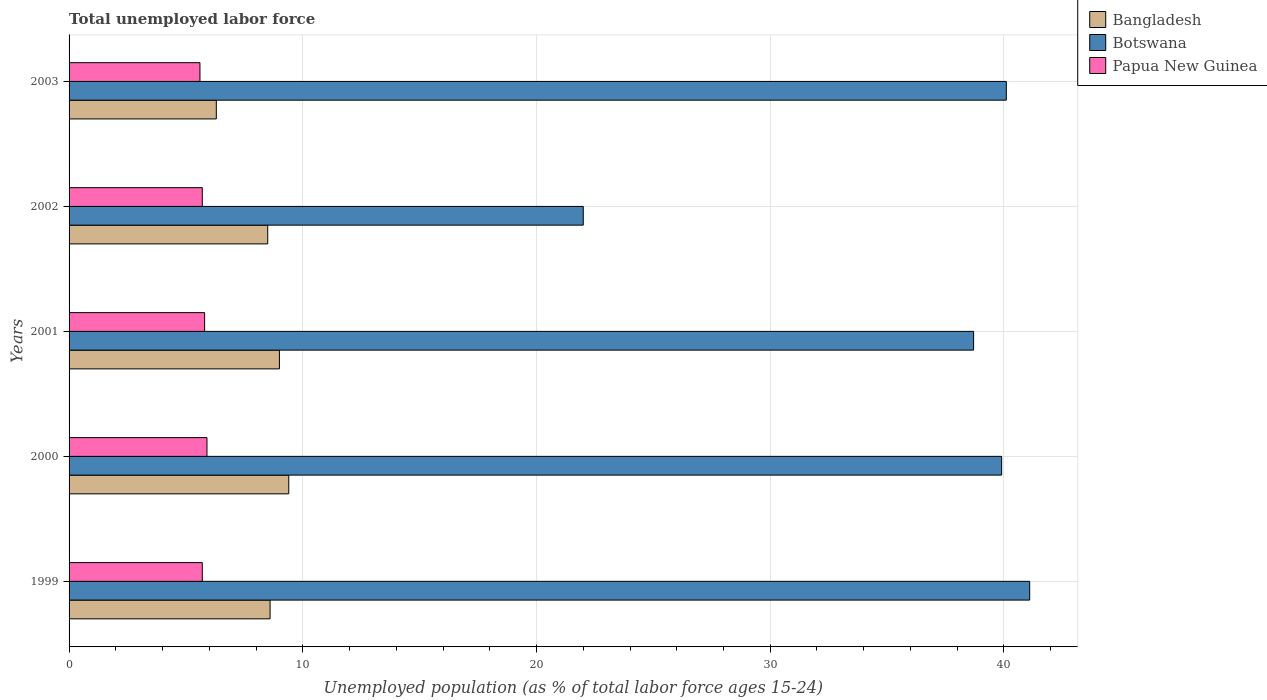How many different coloured bars are there?
Your answer should be compact. 3. How many groups of bars are there?
Offer a terse response. 5. What is the percentage of unemployed population in in Bangladesh in 1999?
Ensure brevity in your answer.  8.6. Across all years, what is the maximum percentage of unemployed population in in Papua New Guinea?
Provide a succinct answer. 5.9. Across all years, what is the minimum percentage of unemployed population in in Botswana?
Give a very brief answer. 22. In which year was the percentage of unemployed population in in Bangladesh maximum?
Your answer should be very brief. 2000. What is the total percentage of unemployed population in in Bangladesh in the graph?
Your response must be concise. 41.8. What is the difference between the percentage of unemployed population in in Botswana in 2001 and that in 2002?
Your answer should be compact. 16.7. What is the difference between the percentage of unemployed population in in Papua New Guinea in 2003 and the percentage of unemployed population in in Botswana in 2002?
Make the answer very short. -16.4. What is the average percentage of unemployed population in in Bangladesh per year?
Keep it short and to the point. 8.36. In the year 2001, what is the difference between the percentage of unemployed population in in Papua New Guinea and percentage of unemployed population in in Botswana?
Make the answer very short. -32.9. What is the ratio of the percentage of unemployed population in in Bangladesh in 2002 to that in 2003?
Offer a terse response. 1.35. Is the percentage of unemployed population in in Papua New Guinea in 2000 less than that in 2003?
Give a very brief answer. No. Is the difference between the percentage of unemployed population in in Papua New Guinea in 2001 and 2003 greater than the difference between the percentage of unemployed population in in Botswana in 2001 and 2003?
Provide a short and direct response. Yes. What is the difference between the highest and the second highest percentage of unemployed population in in Papua New Guinea?
Give a very brief answer. 0.1. What is the difference between the highest and the lowest percentage of unemployed population in in Bangladesh?
Keep it short and to the point. 3.1. Is the sum of the percentage of unemployed population in in Papua New Guinea in 1999 and 2002 greater than the maximum percentage of unemployed population in in Botswana across all years?
Give a very brief answer. No. What does the 1st bar from the top in 2000 represents?
Offer a very short reply. Papua New Guinea. How many bars are there?
Provide a short and direct response. 15. Does the graph contain any zero values?
Make the answer very short. No. Where does the legend appear in the graph?
Your answer should be compact. Top right. How many legend labels are there?
Your answer should be compact. 3. What is the title of the graph?
Provide a short and direct response. Total unemployed labor force. What is the label or title of the X-axis?
Offer a terse response. Unemployed population (as % of total labor force ages 15-24). What is the label or title of the Y-axis?
Your response must be concise. Years. What is the Unemployed population (as % of total labor force ages 15-24) in Bangladesh in 1999?
Your answer should be compact. 8.6. What is the Unemployed population (as % of total labor force ages 15-24) of Botswana in 1999?
Make the answer very short. 41.1. What is the Unemployed population (as % of total labor force ages 15-24) of Papua New Guinea in 1999?
Your answer should be very brief. 5.7. What is the Unemployed population (as % of total labor force ages 15-24) in Bangladesh in 2000?
Make the answer very short. 9.4. What is the Unemployed population (as % of total labor force ages 15-24) in Botswana in 2000?
Offer a very short reply. 39.9. What is the Unemployed population (as % of total labor force ages 15-24) of Papua New Guinea in 2000?
Offer a very short reply. 5.9. What is the Unemployed population (as % of total labor force ages 15-24) in Bangladesh in 2001?
Offer a very short reply. 9. What is the Unemployed population (as % of total labor force ages 15-24) in Botswana in 2001?
Your answer should be compact. 38.7. What is the Unemployed population (as % of total labor force ages 15-24) of Papua New Guinea in 2001?
Offer a terse response. 5.8. What is the Unemployed population (as % of total labor force ages 15-24) in Papua New Guinea in 2002?
Your response must be concise. 5.7. What is the Unemployed population (as % of total labor force ages 15-24) of Bangladesh in 2003?
Offer a very short reply. 6.3. What is the Unemployed population (as % of total labor force ages 15-24) in Botswana in 2003?
Provide a succinct answer. 40.1. What is the Unemployed population (as % of total labor force ages 15-24) in Papua New Guinea in 2003?
Provide a succinct answer. 5.6. Across all years, what is the maximum Unemployed population (as % of total labor force ages 15-24) of Bangladesh?
Offer a very short reply. 9.4. Across all years, what is the maximum Unemployed population (as % of total labor force ages 15-24) in Botswana?
Your response must be concise. 41.1. Across all years, what is the maximum Unemployed population (as % of total labor force ages 15-24) of Papua New Guinea?
Offer a very short reply. 5.9. Across all years, what is the minimum Unemployed population (as % of total labor force ages 15-24) in Bangladesh?
Make the answer very short. 6.3. Across all years, what is the minimum Unemployed population (as % of total labor force ages 15-24) of Botswana?
Give a very brief answer. 22. Across all years, what is the minimum Unemployed population (as % of total labor force ages 15-24) of Papua New Guinea?
Your response must be concise. 5.6. What is the total Unemployed population (as % of total labor force ages 15-24) of Bangladesh in the graph?
Provide a short and direct response. 41.8. What is the total Unemployed population (as % of total labor force ages 15-24) of Botswana in the graph?
Give a very brief answer. 181.8. What is the total Unemployed population (as % of total labor force ages 15-24) in Papua New Guinea in the graph?
Keep it short and to the point. 28.7. What is the difference between the Unemployed population (as % of total labor force ages 15-24) of Papua New Guinea in 1999 and that in 2000?
Offer a terse response. -0.2. What is the difference between the Unemployed population (as % of total labor force ages 15-24) in Papua New Guinea in 1999 and that in 2001?
Provide a succinct answer. -0.1. What is the difference between the Unemployed population (as % of total labor force ages 15-24) of Bangladesh in 1999 and that in 2002?
Your response must be concise. 0.1. What is the difference between the Unemployed population (as % of total labor force ages 15-24) in Bangladesh in 1999 and that in 2003?
Offer a terse response. 2.3. What is the difference between the Unemployed population (as % of total labor force ages 15-24) in Papua New Guinea in 1999 and that in 2003?
Keep it short and to the point. 0.1. What is the difference between the Unemployed population (as % of total labor force ages 15-24) in Bangladesh in 2000 and that in 2002?
Offer a very short reply. 0.9. What is the difference between the Unemployed population (as % of total labor force ages 15-24) in Botswana in 2000 and that in 2002?
Provide a short and direct response. 17.9. What is the difference between the Unemployed population (as % of total labor force ages 15-24) in Papua New Guinea in 2000 and that in 2002?
Make the answer very short. 0.2. What is the difference between the Unemployed population (as % of total labor force ages 15-24) in Botswana in 2000 and that in 2003?
Make the answer very short. -0.2. What is the difference between the Unemployed population (as % of total labor force ages 15-24) of Papua New Guinea in 2001 and that in 2002?
Offer a terse response. 0.1. What is the difference between the Unemployed population (as % of total labor force ages 15-24) in Bangladesh in 2001 and that in 2003?
Your answer should be very brief. 2.7. What is the difference between the Unemployed population (as % of total labor force ages 15-24) of Botswana in 2001 and that in 2003?
Offer a very short reply. -1.4. What is the difference between the Unemployed population (as % of total labor force ages 15-24) in Botswana in 2002 and that in 2003?
Provide a short and direct response. -18.1. What is the difference between the Unemployed population (as % of total labor force ages 15-24) in Papua New Guinea in 2002 and that in 2003?
Make the answer very short. 0.1. What is the difference between the Unemployed population (as % of total labor force ages 15-24) of Bangladesh in 1999 and the Unemployed population (as % of total labor force ages 15-24) of Botswana in 2000?
Ensure brevity in your answer.  -31.3. What is the difference between the Unemployed population (as % of total labor force ages 15-24) of Botswana in 1999 and the Unemployed population (as % of total labor force ages 15-24) of Papua New Guinea in 2000?
Provide a succinct answer. 35.2. What is the difference between the Unemployed population (as % of total labor force ages 15-24) in Bangladesh in 1999 and the Unemployed population (as % of total labor force ages 15-24) in Botswana in 2001?
Your answer should be compact. -30.1. What is the difference between the Unemployed population (as % of total labor force ages 15-24) of Bangladesh in 1999 and the Unemployed population (as % of total labor force ages 15-24) of Papua New Guinea in 2001?
Provide a short and direct response. 2.8. What is the difference between the Unemployed population (as % of total labor force ages 15-24) of Botswana in 1999 and the Unemployed population (as % of total labor force ages 15-24) of Papua New Guinea in 2001?
Provide a short and direct response. 35.3. What is the difference between the Unemployed population (as % of total labor force ages 15-24) of Bangladesh in 1999 and the Unemployed population (as % of total labor force ages 15-24) of Papua New Guinea in 2002?
Give a very brief answer. 2.9. What is the difference between the Unemployed population (as % of total labor force ages 15-24) of Botswana in 1999 and the Unemployed population (as % of total labor force ages 15-24) of Papua New Guinea in 2002?
Give a very brief answer. 35.4. What is the difference between the Unemployed population (as % of total labor force ages 15-24) in Bangladesh in 1999 and the Unemployed population (as % of total labor force ages 15-24) in Botswana in 2003?
Make the answer very short. -31.5. What is the difference between the Unemployed population (as % of total labor force ages 15-24) of Botswana in 1999 and the Unemployed population (as % of total labor force ages 15-24) of Papua New Guinea in 2003?
Keep it short and to the point. 35.5. What is the difference between the Unemployed population (as % of total labor force ages 15-24) of Bangladesh in 2000 and the Unemployed population (as % of total labor force ages 15-24) of Botswana in 2001?
Provide a short and direct response. -29.3. What is the difference between the Unemployed population (as % of total labor force ages 15-24) in Botswana in 2000 and the Unemployed population (as % of total labor force ages 15-24) in Papua New Guinea in 2001?
Provide a short and direct response. 34.1. What is the difference between the Unemployed population (as % of total labor force ages 15-24) in Bangladesh in 2000 and the Unemployed population (as % of total labor force ages 15-24) in Botswana in 2002?
Keep it short and to the point. -12.6. What is the difference between the Unemployed population (as % of total labor force ages 15-24) in Botswana in 2000 and the Unemployed population (as % of total labor force ages 15-24) in Papua New Guinea in 2002?
Offer a very short reply. 34.2. What is the difference between the Unemployed population (as % of total labor force ages 15-24) of Bangladesh in 2000 and the Unemployed population (as % of total labor force ages 15-24) of Botswana in 2003?
Your response must be concise. -30.7. What is the difference between the Unemployed population (as % of total labor force ages 15-24) of Botswana in 2000 and the Unemployed population (as % of total labor force ages 15-24) of Papua New Guinea in 2003?
Make the answer very short. 34.3. What is the difference between the Unemployed population (as % of total labor force ages 15-24) of Bangladesh in 2001 and the Unemployed population (as % of total labor force ages 15-24) of Botswana in 2002?
Offer a terse response. -13. What is the difference between the Unemployed population (as % of total labor force ages 15-24) of Bangladesh in 2001 and the Unemployed population (as % of total labor force ages 15-24) of Papua New Guinea in 2002?
Offer a very short reply. 3.3. What is the difference between the Unemployed population (as % of total labor force ages 15-24) in Botswana in 2001 and the Unemployed population (as % of total labor force ages 15-24) in Papua New Guinea in 2002?
Offer a very short reply. 33. What is the difference between the Unemployed population (as % of total labor force ages 15-24) in Bangladesh in 2001 and the Unemployed population (as % of total labor force ages 15-24) in Botswana in 2003?
Offer a very short reply. -31.1. What is the difference between the Unemployed population (as % of total labor force ages 15-24) in Botswana in 2001 and the Unemployed population (as % of total labor force ages 15-24) in Papua New Guinea in 2003?
Make the answer very short. 33.1. What is the difference between the Unemployed population (as % of total labor force ages 15-24) of Bangladesh in 2002 and the Unemployed population (as % of total labor force ages 15-24) of Botswana in 2003?
Your answer should be compact. -31.6. What is the difference between the Unemployed population (as % of total labor force ages 15-24) in Bangladesh in 2002 and the Unemployed population (as % of total labor force ages 15-24) in Papua New Guinea in 2003?
Make the answer very short. 2.9. What is the difference between the Unemployed population (as % of total labor force ages 15-24) in Botswana in 2002 and the Unemployed population (as % of total labor force ages 15-24) in Papua New Guinea in 2003?
Give a very brief answer. 16.4. What is the average Unemployed population (as % of total labor force ages 15-24) of Bangladesh per year?
Offer a terse response. 8.36. What is the average Unemployed population (as % of total labor force ages 15-24) of Botswana per year?
Your answer should be compact. 36.36. What is the average Unemployed population (as % of total labor force ages 15-24) in Papua New Guinea per year?
Your response must be concise. 5.74. In the year 1999, what is the difference between the Unemployed population (as % of total labor force ages 15-24) of Bangladesh and Unemployed population (as % of total labor force ages 15-24) of Botswana?
Offer a very short reply. -32.5. In the year 1999, what is the difference between the Unemployed population (as % of total labor force ages 15-24) of Bangladesh and Unemployed population (as % of total labor force ages 15-24) of Papua New Guinea?
Keep it short and to the point. 2.9. In the year 1999, what is the difference between the Unemployed population (as % of total labor force ages 15-24) in Botswana and Unemployed population (as % of total labor force ages 15-24) in Papua New Guinea?
Offer a terse response. 35.4. In the year 2000, what is the difference between the Unemployed population (as % of total labor force ages 15-24) in Bangladesh and Unemployed population (as % of total labor force ages 15-24) in Botswana?
Offer a terse response. -30.5. In the year 2000, what is the difference between the Unemployed population (as % of total labor force ages 15-24) of Botswana and Unemployed population (as % of total labor force ages 15-24) of Papua New Guinea?
Keep it short and to the point. 34. In the year 2001, what is the difference between the Unemployed population (as % of total labor force ages 15-24) of Bangladesh and Unemployed population (as % of total labor force ages 15-24) of Botswana?
Your answer should be very brief. -29.7. In the year 2001, what is the difference between the Unemployed population (as % of total labor force ages 15-24) of Botswana and Unemployed population (as % of total labor force ages 15-24) of Papua New Guinea?
Keep it short and to the point. 32.9. In the year 2003, what is the difference between the Unemployed population (as % of total labor force ages 15-24) of Bangladesh and Unemployed population (as % of total labor force ages 15-24) of Botswana?
Provide a short and direct response. -33.8. In the year 2003, what is the difference between the Unemployed population (as % of total labor force ages 15-24) of Bangladesh and Unemployed population (as % of total labor force ages 15-24) of Papua New Guinea?
Provide a short and direct response. 0.7. In the year 2003, what is the difference between the Unemployed population (as % of total labor force ages 15-24) of Botswana and Unemployed population (as % of total labor force ages 15-24) of Papua New Guinea?
Keep it short and to the point. 34.5. What is the ratio of the Unemployed population (as % of total labor force ages 15-24) of Bangladesh in 1999 to that in 2000?
Provide a short and direct response. 0.91. What is the ratio of the Unemployed population (as % of total labor force ages 15-24) of Botswana in 1999 to that in 2000?
Offer a very short reply. 1.03. What is the ratio of the Unemployed population (as % of total labor force ages 15-24) in Papua New Guinea in 1999 to that in 2000?
Give a very brief answer. 0.97. What is the ratio of the Unemployed population (as % of total labor force ages 15-24) in Bangladesh in 1999 to that in 2001?
Your answer should be very brief. 0.96. What is the ratio of the Unemployed population (as % of total labor force ages 15-24) in Botswana in 1999 to that in 2001?
Your answer should be very brief. 1.06. What is the ratio of the Unemployed population (as % of total labor force ages 15-24) in Papua New Guinea in 1999 to that in 2001?
Make the answer very short. 0.98. What is the ratio of the Unemployed population (as % of total labor force ages 15-24) in Bangladesh in 1999 to that in 2002?
Ensure brevity in your answer.  1.01. What is the ratio of the Unemployed population (as % of total labor force ages 15-24) of Botswana in 1999 to that in 2002?
Provide a short and direct response. 1.87. What is the ratio of the Unemployed population (as % of total labor force ages 15-24) of Bangladesh in 1999 to that in 2003?
Your answer should be very brief. 1.37. What is the ratio of the Unemployed population (as % of total labor force ages 15-24) in Botswana in 1999 to that in 2003?
Give a very brief answer. 1.02. What is the ratio of the Unemployed population (as % of total labor force ages 15-24) of Papua New Guinea in 1999 to that in 2003?
Your response must be concise. 1.02. What is the ratio of the Unemployed population (as % of total labor force ages 15-24) of Bangladesh in 2000 to that in 2001?
Offer a terse response. 1.04. What is the ratio of the Unemployed population (as % of total labor force ages 15-24) of Botswana in 2000 to that in 2001?
Ensure brevity in your answer.  1.03. What is the ratio of the Unemployed population (as % of total labor force ages 15-24) in Papua New Guinea in 2000 to that in 2001?
Your answer should be compact. 1.02. What is the ratio of the Unemployed population (as % of total labor force ages 15-24) of Bangladesh in 2000 to that in 2002?
Provide a short and direct response. 1.11. What is the ratio of the Unemployed population (as % of total labor force ages 15-24) in Botswana in 2000 to that in 2002?
Offer a very short reply. 1.81. What is the ratio of the Unemployed population (as % of total labor force ages 15-24) in Papua New Guinea in 2000 to that in 2002?
Give a very brief answer. 1.04. What is the ratio of the Unemployed population (as % of total labor force ages 15-24) in Bangladesh in 2000 to that in 2003?
Keep it short and to the point. 1.49. What is the ratio of the Unemployed population (as % of total labor force ages 15-24) of Papua New Guinea in 2000 to that in 2003?
Provide a succinct answer. 1.05. What is the ratio of the Unemployed population (as % of total labor force ages 15-24) of Bangladesh in 2001 to that in 2002?
Offer a terse response. 1.06. What is the ratio of the Unemployed population (as % of total labor force ages 15-24) of Botswana in 2001 to that in 2002?
Keep it short and to the point. 1.76. What is the ratio of the Unemployed population (as % of total labor force ages 15-24) in Papua New Guinea in 2001 to that in 2002?
Give a very brief answer. 1.02. What is the ratio of the Unemployed population (as % of total labor force ages 15-24) in Bangladesh in 2001 to that in 2003?
Make the answer very short. 1.43. What is the ratio of the Unemployed population (as % of total labor force ages 15-24) of Botswana in 2001 to that in 2003?
Give a very brief answer. 0.97. What is the ratio of the Unemployed population (as % of total labor force ages 15-24) in Papua New Guinea in 2001 to that in 2003?
Provide a succinct answer. 1.04. What is the ratio of the Unemployed population (as % of total labor force ages 15-24) in Bangladesh in 2002 to that in 2003?
Ensure brevity in your answer.  1.35. What is the ratio of the Unemployed population (as % of total labor force ages 15-24) in Botswana in 2002 to that in 2003?
Offer a terse response. 0.55. What is the ratio of the Unemployed population (as % of total labor force ages 15-24) of Papua New Guinea in 2002 to that in 2003?
Your answer should be compact. 1.02. What is the difference between the highest and the second highest Unemployed population (as % of total labor force ages 15-24) of Bangladesh?
Provide a succinct answer. 0.4. What is the difference between the highest and the lowest Unemployed population (as % of total labor force ages 15-24) of Bangladesh?
Offer a terse response. 3.1. What is the difference between the highest and the lowest Unemployed population (as % of total labor force ages 15-24) in Botswana?
Provide a succinct answer. 19.1. 